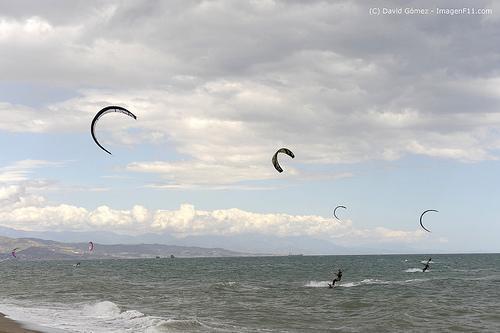How many windsurfers are riding the winds at the moment in the image?
Give a very brief answer. 6. 